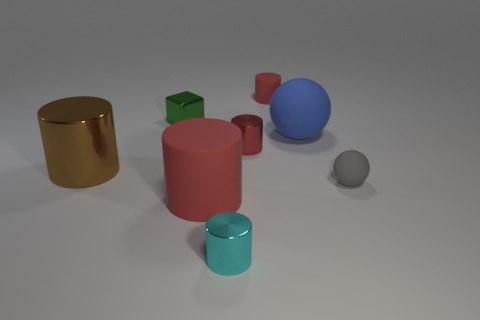There is a blue rubber object that is the same size as the brown metal thing; what is its shape?
Provide a short and direct response. Sphere. What number of things are tiny matte objects that are to the left of the tiny gray matte ball or small blue metallic balls?
Provide a short and direct response. 1. Is the color of the small matte cylinder the same as the small block?
Offer a terse response. No. There is a red matte cylinder that is behind the big red matte object; what is its size?
Your response must be concise. Small. Are there any green cubes of the same size as the gray sphere?
Provide a succinct answer. Yes. There is a red cylinder behind the red shiny cylinder; is it the same size as the cyan shiny cylinder?
Your answer should be compact. Yes. The cyan object is what size?
Your answer should be compact. Small. The tiny object that is to the left of the red rubber cylinder that is in front of the small gray thing that is on the right side of the small green cube is what color?
Make the answer very short. Green. There is a rubber cylinder that is right of the cyan cylinder; does it have the same color as the big rubber cylinder?
Ensure brevity in your answer.  Yes. What number of small cylinders are both on the right side of the tiny cyan metal cylinder and in front of the tiny red metal object?
Provide a succinct answer. 0. 